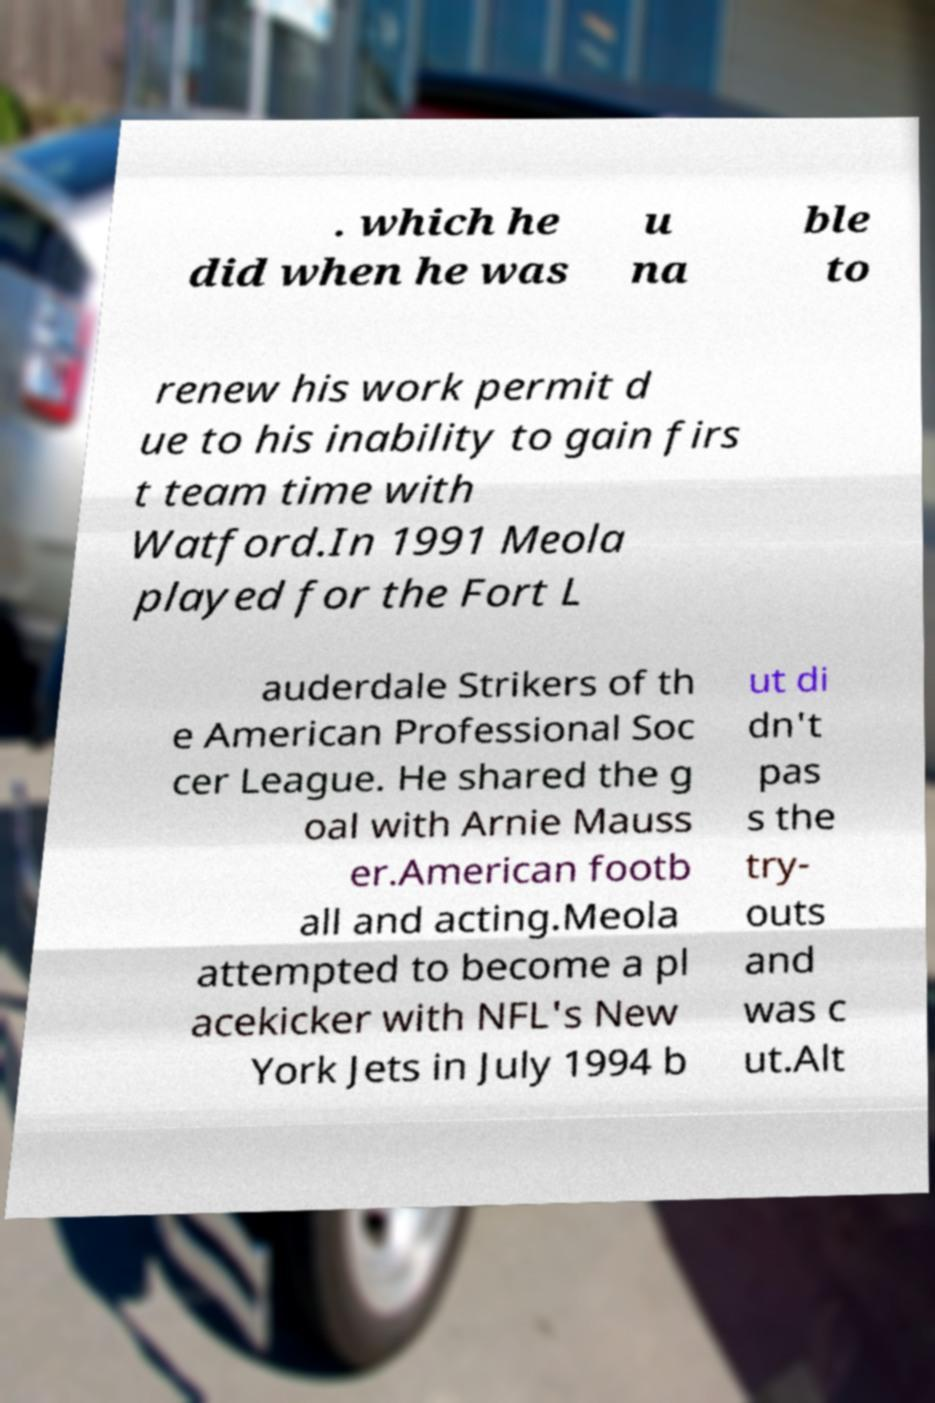Can you read and provide the text displayed in the image?This photo seems to have some interesting text. Can you extract and type it out for me? . which he did when he was u na ble to renew his work permit d ue to his inability to gain firs t team time with Watford.In 1991 Meola played for the Fort L auderdale Strikers of th e American Professional Soc cer League. He shared the g oal with Arnie Mauss er.American footb all and acting.Meola attempted to become a pl acekicker with NFL's New York Jets in July 1994 b ut di dn't pas s the try- outs and was c ut.Alt 